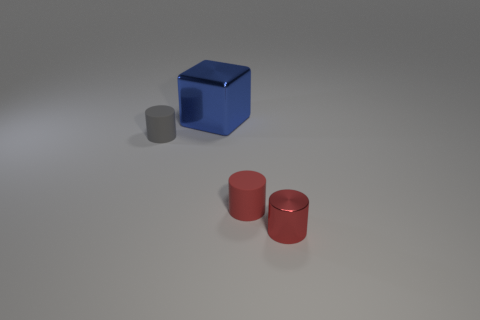Add 4 large blocks. How many objects exist? 8 Subtract all cylinders. How many objects are left? 1 Add 2 big green cylinders. How many big green cylinders exist? 2 Subtract 0 green blocks. How many objects are left? 4 Subtract all tiny red metallic objects. Subtract all blue metallic cubes. How many objects are left? 2 Add 3 rubber things. How many rubber things are left? 5 